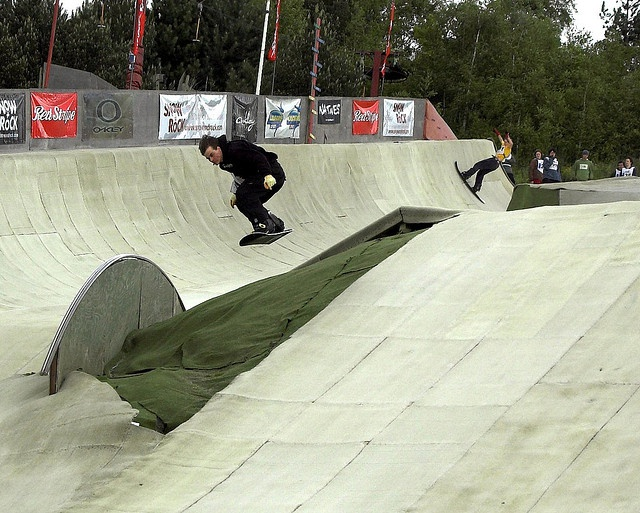Describe the objects in this image and their specific colors. I can see people in gray, black, and darkgray tones, people in gray, black, darkgray, and lightgray tones, people in gray, black, and lightgray tones, people in gray, darkgreen, and black tones, and snowboard in gray, black, lightgray, and darkgray tones in this image. 